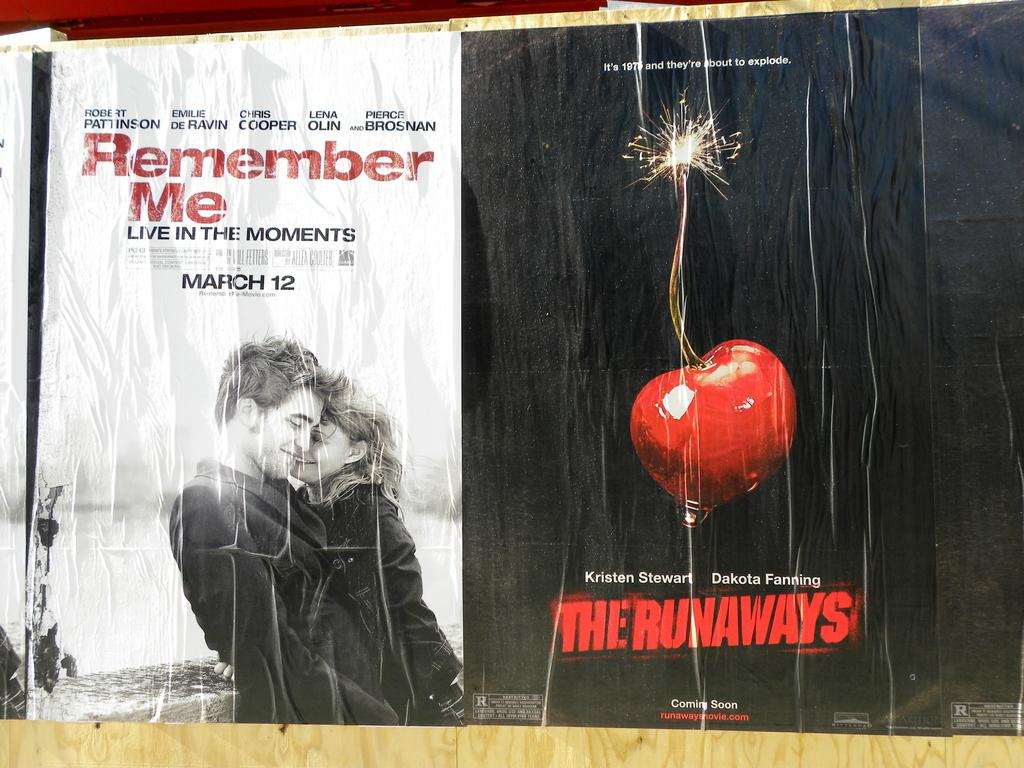What is featured on the poster in the image? There is a poster in the image that has text on it. What images are depicted on the poster? The poster has a picture of a man and a picture of a woman on it. What type of vessel is being used for the voyage depicted in the image? There is no voyage or vessel present in the image; it only features a poster with text and images of a man and a woman. 